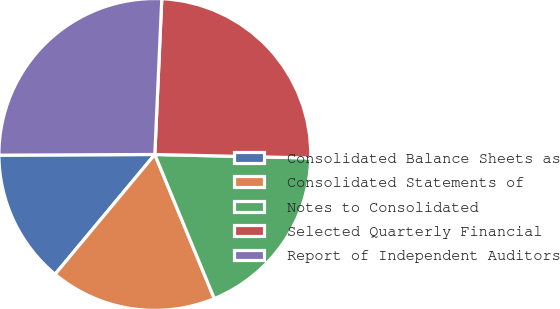Convert chart. <chart><loc_0><loc_0><loc_500><loc_500><pie_chart><fcel>Consolidated Balance Sheets as<fcel>Consolidated Statements of<fcel>Notes to Consolidated<fcel>Selected Quarterly Financial<fcel>Report of Independent Auditors<nl><fcel>13.88%<fcel>17.28%<fcel>18.41%<fcel>24.65%<fcel>25.78%<nl></chart> 